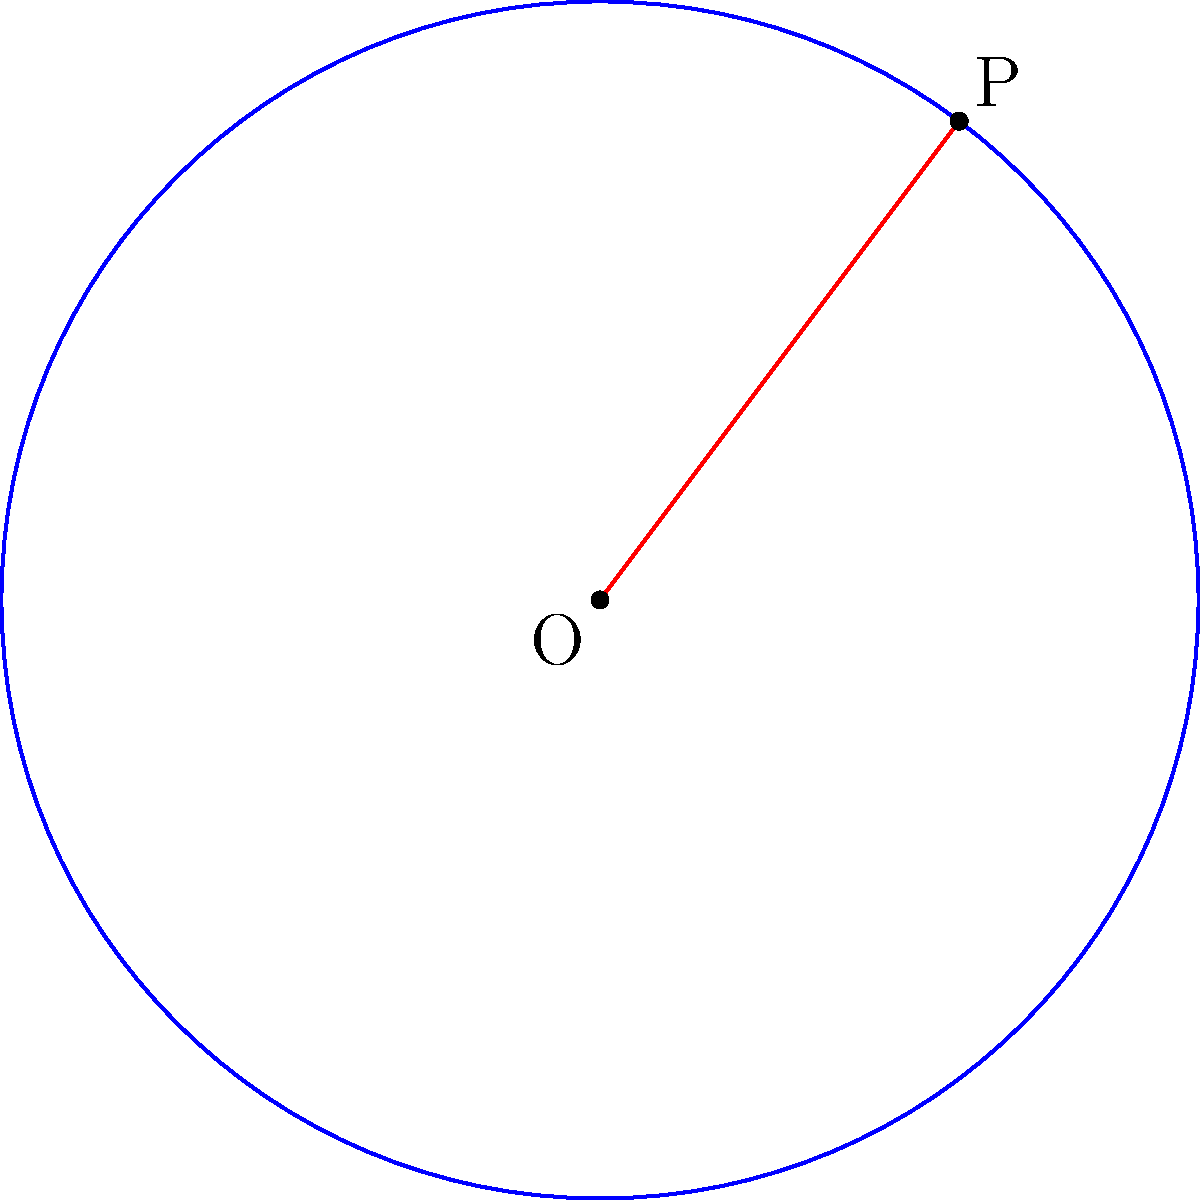Given a circle with center O(2,3) and a point P(5,7) on its circumference, determine the equation of the circle. Present your answer in standard form: $(x-h)^2 + (y-k)^2 = r^2$, where (h,k) is the center and r is the radius. To find the equation of the circle, we need to:

1. Identify the center (h,k):
   The center O is given as (2,3), so h = 2 and k = 3.

2. Calculate the radius r:
   We can find the radius by calculating the distance between O and P using the distance formula:

   $r = \sqrt{(x_2-x_1)^2 + (y_2-y_1)^2}$
   $r = \sqrt{(5-2)^2 + (7-3)^2}$
   $r = \sqrt{3^2 + 4^2}$
   $r = \sqrt{9 + 16}$
   $r = \sqrt{25}$
   $r = 5$

3. Substitute the values into the standard form equation:
   $(x-h)^2 + (y-k)^2 = r^2$
   $(x-2)^2 + (y-3)^2 = 5^2$

Therefore, the equation of the circle is $(x-2)^2 + (y-3)^2 = 25$.
Answer: $(x-2)^2 + (y-3)^2 = 25$ 